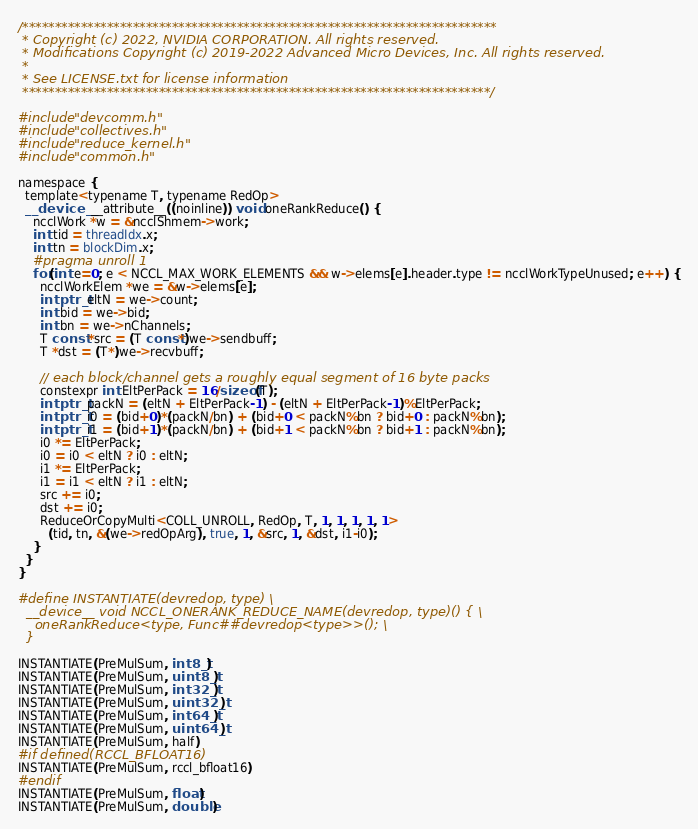<code> <loc_0><loc_0><loc_500><loc_500><_Cuda_>/*************************************************************************
 * Copyright (c) 2022, NVIDIA CORPORATION. All rights reserved.
 * Modifications Copyright (c) 2019-2022 Advanced Micro Devices, Inc. All rights reserved.
 *
 * See LICENSE.txt for license information
 ************************************************************************/

#include "devcomm.h"
#include "collectives.h"
#include "reduce_kernel.h"
#include "common.h"

namespace {
  template<typename T, typename RedOp>
  __device__ __attribute__((noinline)) void oneRankReduce() {
    ncclWork *w = &ncclShmem->work;
    int tid = threadIdx.x;
    int tn = blockDim.x;
    #pragma unroll 1
    for(int e=0; e < NCCL_MAX_WORK_ELEMENTS && w->elems[e].header.type != ncclWorkTypeUnused; e++) {
      ncclWorkElem *we = &w->elems[e];
      intptr_t eltN = we->count;
      int bid = we->bid;
      int bn = we->nChannels;
      T const *src = (T const*)we->sendbuff;
      T *dst = (T*)we->recvbuff;

      // each block/channel gets a roughly equal segment of 16 byte packs
      constexpr int EltPerPack = 16/sizeof(T);
      intptr_t packN = (eltN + EltPerPack-1) - (eltN + EltPerPack-1)%EltPerPack;
      intptr_t i0 = (bid+0)*(packN/bn) + (bid+0 < packN%bn ? bid+0 : packN%bn);
      intptr_t i1 = (bid+1)*(packN/bn) + (bid+1 < packN%bn ? bid+1 : packN%bn);
      i0 *= EltPerPack;
      i0 = i0 < eltN ? i0 : eltN;
      i1 *= EltPerPack;
      i1 = i1 < eltN ? i1 : eltN;
      src += i0;
      dst += i0;
      ReduceOrCopyMulti<COLL_UNROLL, RedOp, T, 1, 1, 1, 1, 1>
        (tid, tn, &(we->redOpArg), true, 1, &src, 1, &dst, i1-i0);
    }
  }
}

#define INSTANTIATE(devredop, type) \
  __device__ void NCCL_ONERANK_REDUCE_NAME(devredop, type)() { \
    oneRankReduce<type, Func##devredop<type>>(); \
  }

INSTANTIATE(PreMulSum, int8_t)
INSTANTIATE(PreMulSum, uint8_t)
INSTANTIATE(PreMulSum, int32_t)
INSTANTIATE(PreMulSum, uint32_t)
INSTANTIATE(PreMulSum, int64_t)
INSTANTIATE(PreMulSum, uint64_t)
INSTANTIATE(PreMulSum, half)
#if defined(RCCL_BFLOAT16)
INSTANTIATE(PreMulSum, rccl_bfloat16)
#endif
INSTANTIATE(PreMulSum, float)
INSTANTIATE(PreMulSum, double)
</code> 